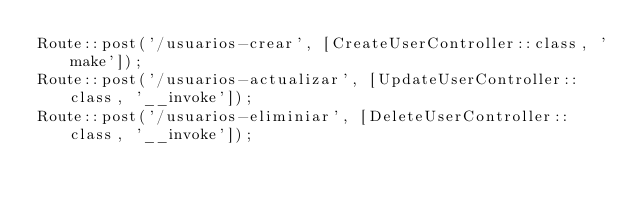<code> <loc_0><loc_0><loc_500><loc_500><_PHP_>Route::post('/usuarios-crear', [CreateUserController::class, 'make']);
Route::post('/usuarios-actualizar', [UpdateUserController::class, '__invoke']);
Route::post('/usuarios-eliminiar', [DeleteUserController::class, '__invoke']);
</code> 